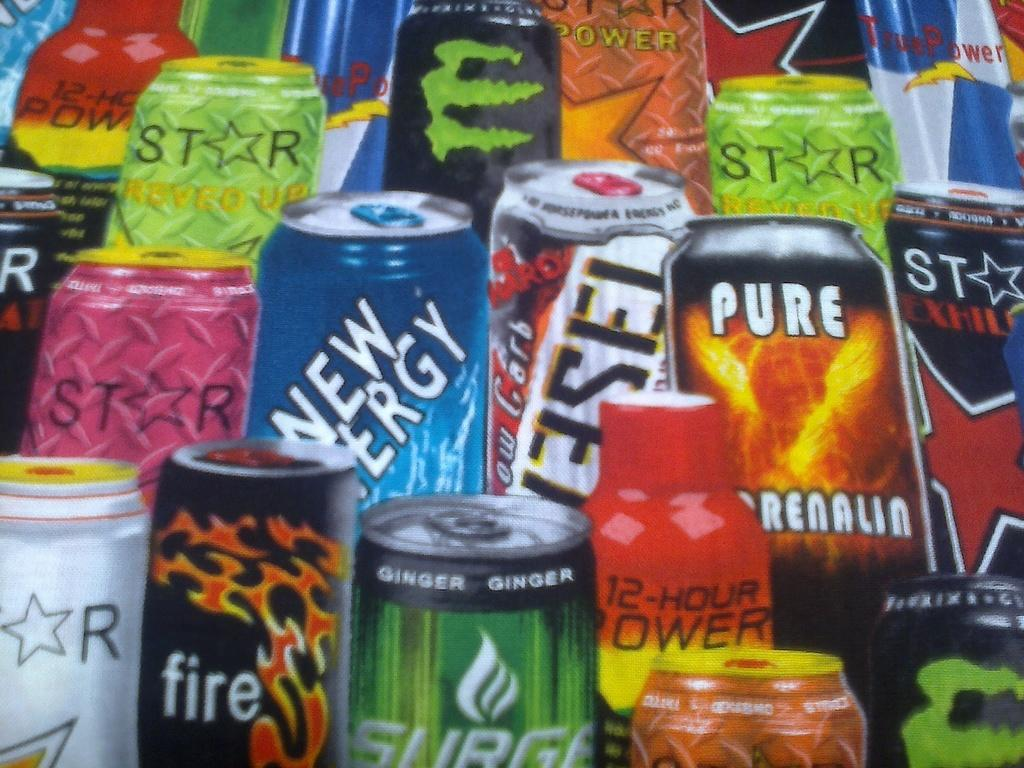What type of beverage containers are present in the image? There are coke cans in the image. How do the coke cans differ from one another? The coke cans have different colors. What is written on the coke cans? There is text on each coke can. Where is the pipe located in the image? There is no pipe present in the image. What type of hall can be seen in the background of the image? There is no hall visible in the image; it only features coke cans. 